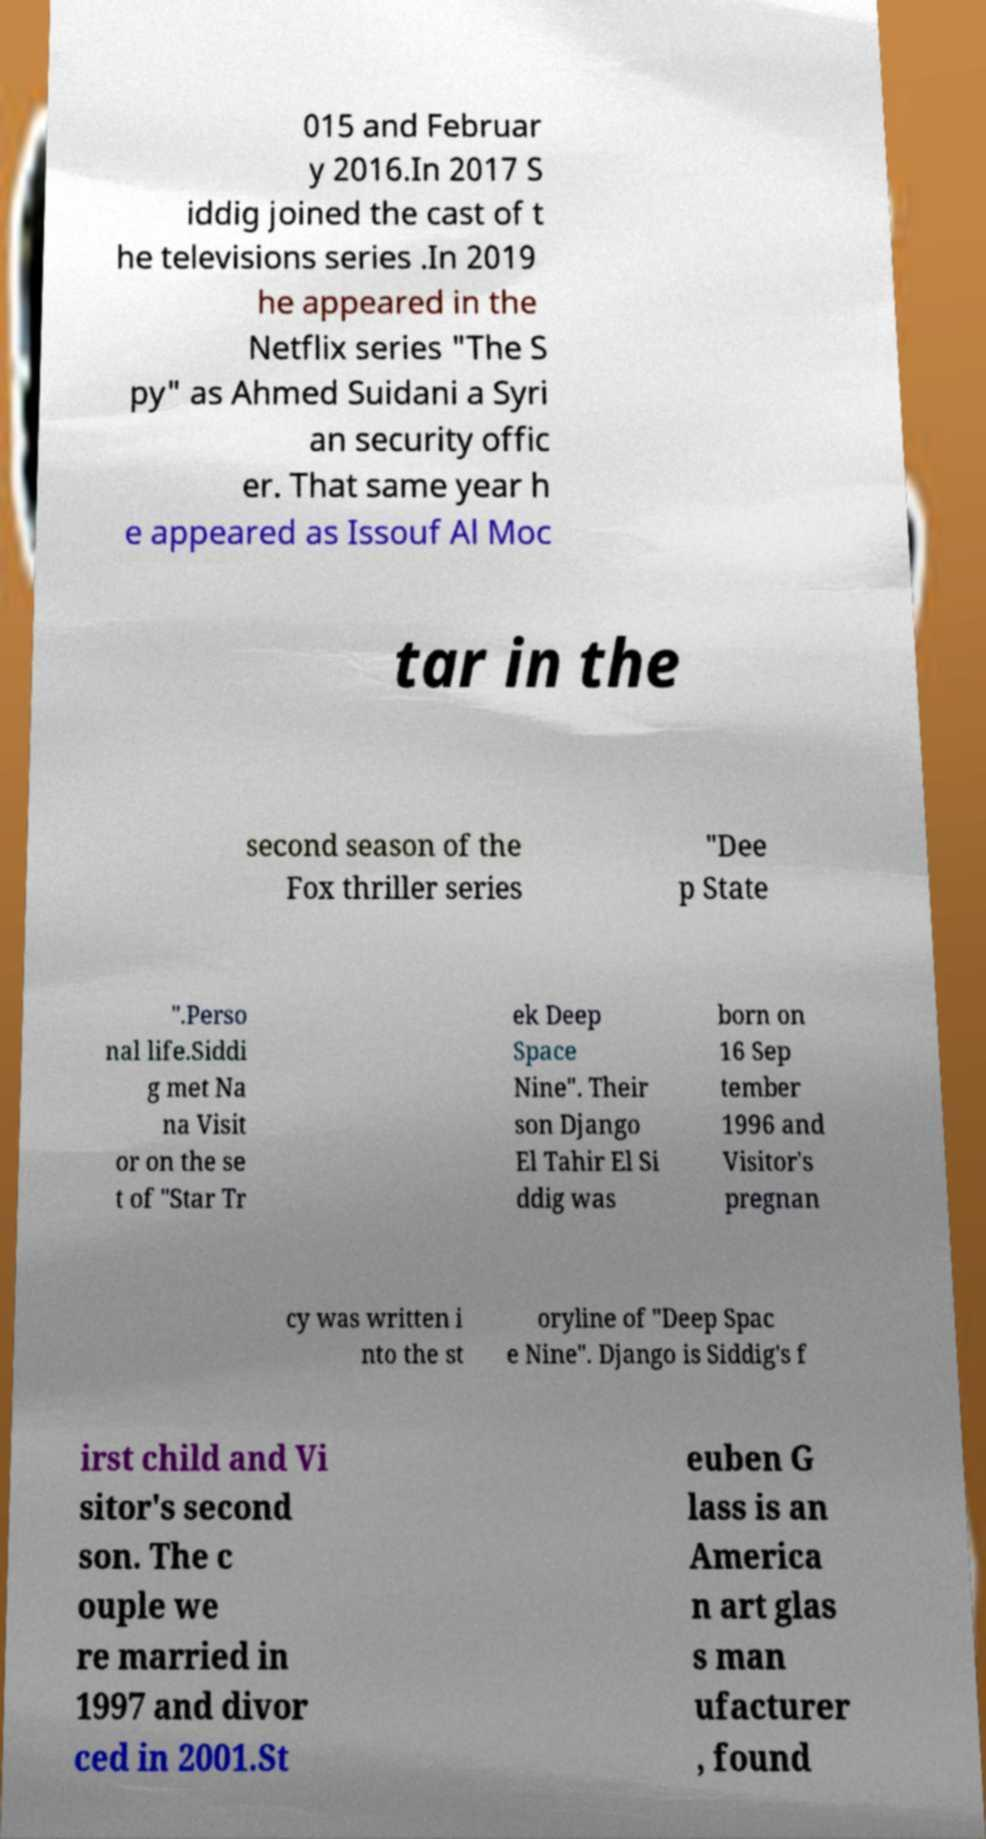Can you accurately transcribe the text from the provided image for me? 015 and Februar y 2016.In 2017 S iddig joined the cast of t he televisions series .In 2019 he appeared in the Netflix series "The S py" as Ahmed Suidani a Syri an security offic er. That same year h e appeared as Issouf Al Moc tar in the second season of the Fox thriller series "Dee p State ".Perso nal life.Siddi g met Na na Visit or on the se t of "Star Tr ek Deep Space Nine". Their son Django El Tahir El Si ddig was born on 16 Sep tember 1996 and Visitor's pregnan cy was written i nto the st oryline of "Deep Spac e Nine". Django is Siddig's f irst child and Vi sitor's second son. The c ouple we re married in 1997 and divor ced in 2001.St euben G lass is an America n art glas s man ufacturer , found 